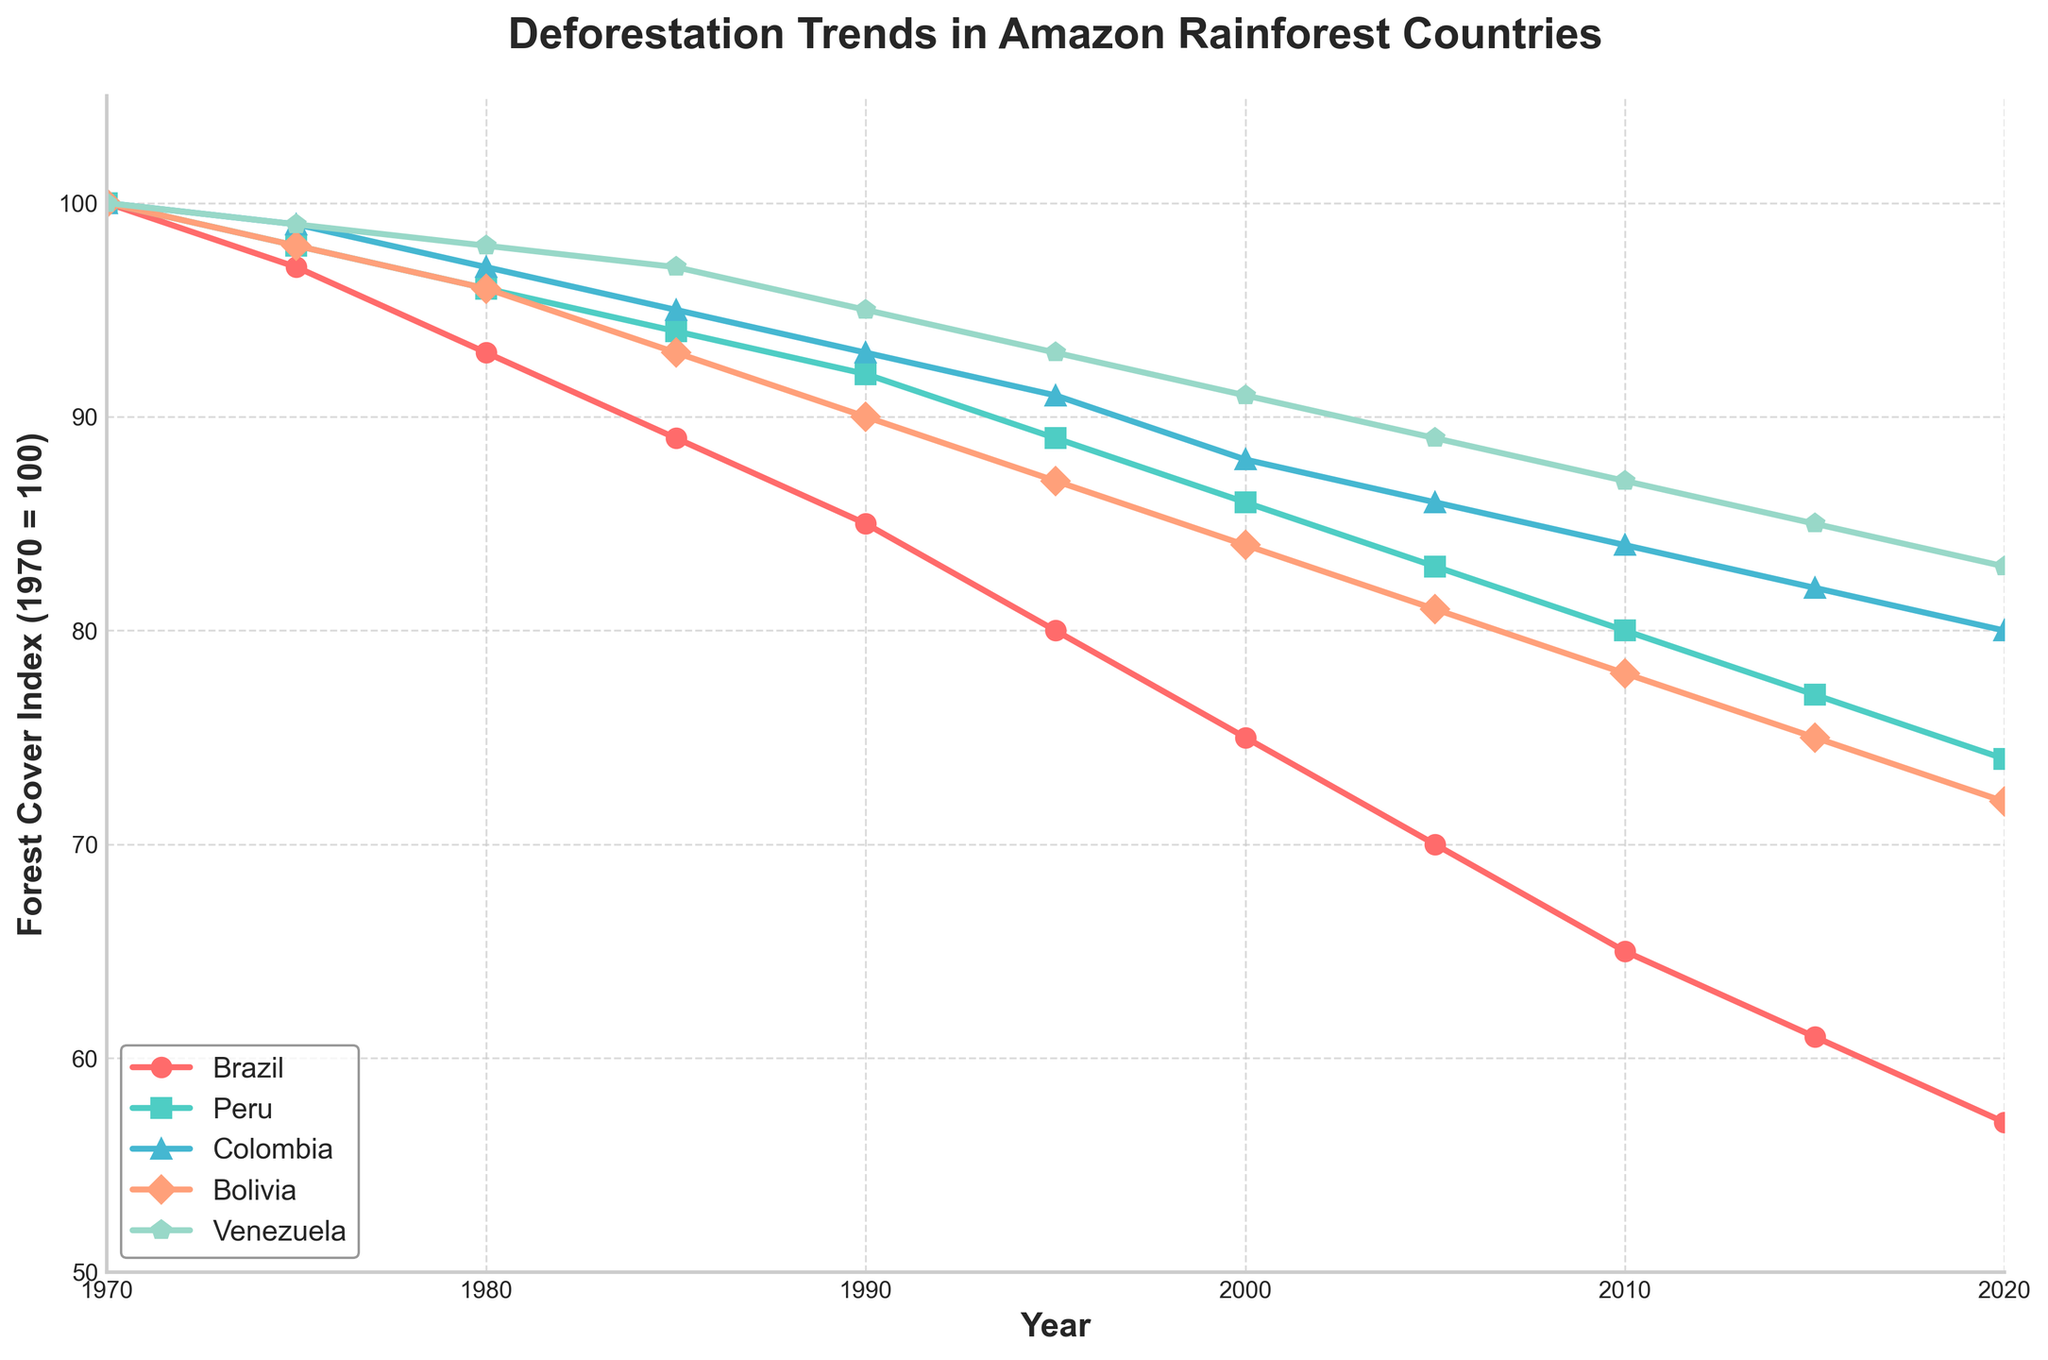Which country experienced the highest rate of deforestation between 1970 and 2020? To find the country with the highest rate of deforestation, we need to compare the changes in the forest cover index for each country from 1970 to 2020. Brazil's forest cover index dropped from 100 to 57, the largest decrease among all countries.
Answer: Brazil Which country had the slowest rate of deforestation by 2020? To determine the country with the slowest rate of deforestation, compare the forest cover indices in 2020. Venezuela's index decreased from 100 to 83, which is the smallest decrease.
Answer: Venezuela By how much did Brazil's forest cover index decrease between 1980 and 2010? Examine the forest cover index for Brazil in 1980 (93) and 2010 (65). Subtract the 2010 index from the 1980 index: 93 - 65 = 28.
Answer: 28 In which decade did Bolivia experience the largest decrease in forest cover index? Compare the changes in Bolivia’s forest cover index for each decade: 1970s (2), 1980s (3), 1990s (3), 2000s (3). The differences are the same, but visually, the drop appears largest in percentage terms in the 1970s.
Answer: 1970s How does Peru's deforestation trend between 2000 and 2020 compare to Colombia’s in that interval? Analyze the indices for Peru and Colombia between 2000 and 2020: Peru decreased from 86 to 74 (12 points), while Colombia decreased from 88 to 80 (8 points). Peru experienced a larger decrease.
Answer: Peru had a larger decrease Which two countries have the closest forest cover index values in 2020? Compare the 2020 forest cover indices: Brazil (57), Peru (74), Colombia (80), Bolivia (72), Venezuela (83). The closest values are for Bolivia (72) and Peru (74).
Answer: Bolivia and Peru What is the trend in Venezuela's forest cover index from 1970 to 2020? Observe the continuous decline in forest cover index for Venezuela: 100 (1970) to 83 (2020). The trend is a consistent decrease over time.
Answer: Consistent decrease On average, how much did Brazil's forest cover index decrease every decade from 1970 to 2020? Calculate the total decrease (100 - 57 = 43) and divide by the number of decades (5): 43 / 5 = 8.6.
Answer: 8.6 per decade In 2010, which country had a forest cover index closest to 80? Observe the forest cover indices in 2010: Brazil (65), Peru (80), Colombia (84), Bolivia (78), Venezuela (87). Peru is closest to 80.
Answer: Peru 